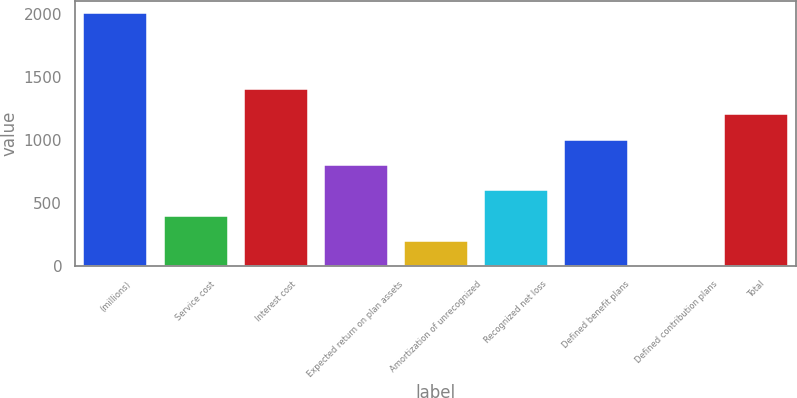Convert chart. <chart><loc_0><loc_0><loc_500><loc_500><bar_chart><fcel>(millions)<fcel>Service cost<fcel>Interest cost<fcel>Expected return on plan assets<fcel>Amortization of unrecognized<fcel>Recognized net loss<fcel>Defined benefit plans<fcel>Defined contribution plans<fcel>Total<nl><fcel>2005<fcel>402.04<fcel>1403.89<fcel>802.78<fcel>201.67<fcel>602.41<fcel>1003.15<fcel>1.3<fcel>1203.52<nl></chart> 